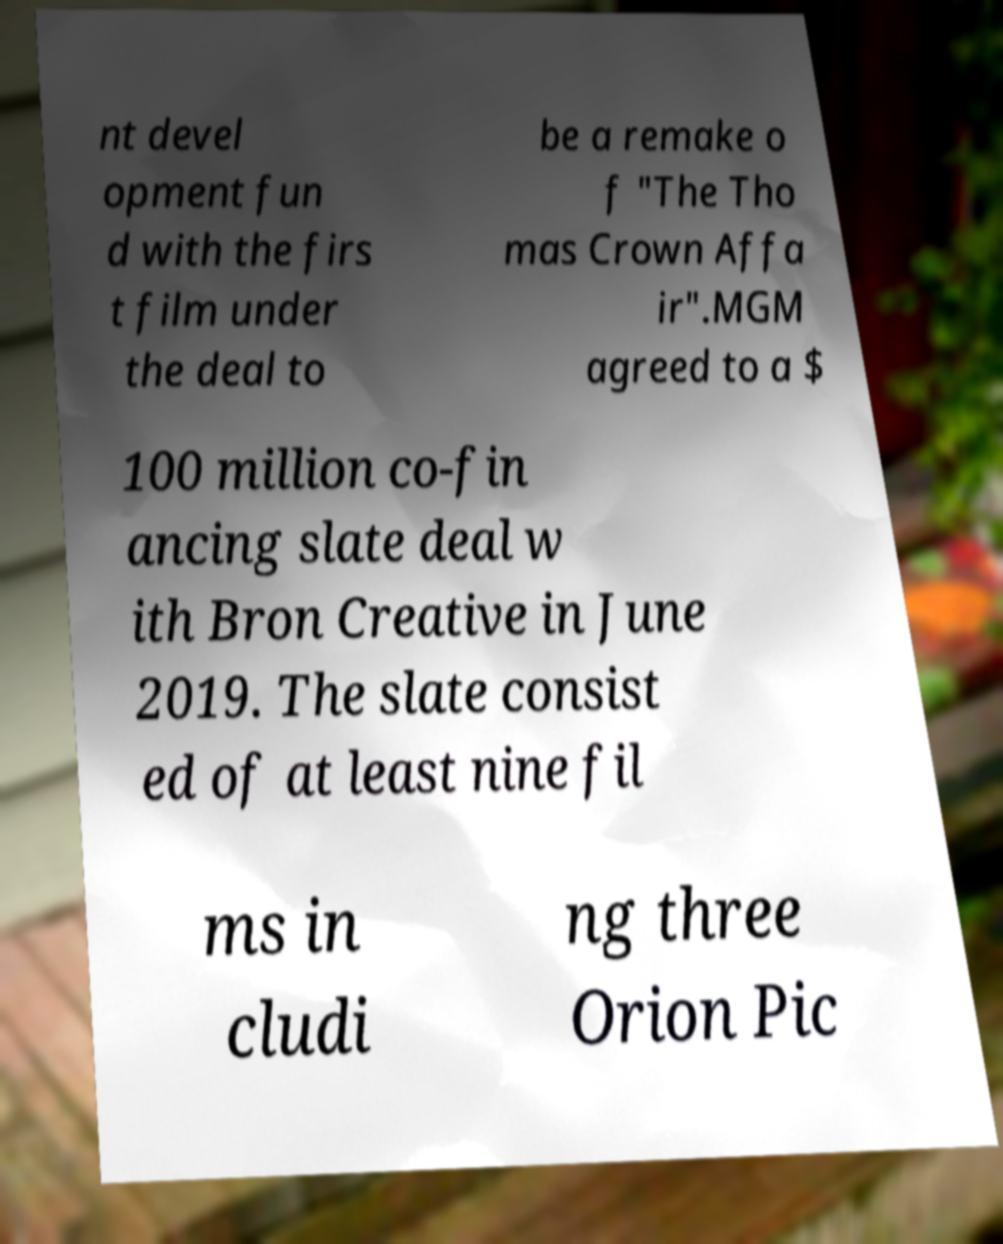For documentation purposes, I need the text within this image transcribed. Could you provide that? nt devel opment fun d with the firs t film under the deal to be a remake o f "The Tho mas Crown Affa ir".MGM agreed to a $ 100 million co-fin ancing slate deal w ith Bron Creative in June 2019. The slate consist ed of at least nine fil ms in cludi ng three Orion Pic 